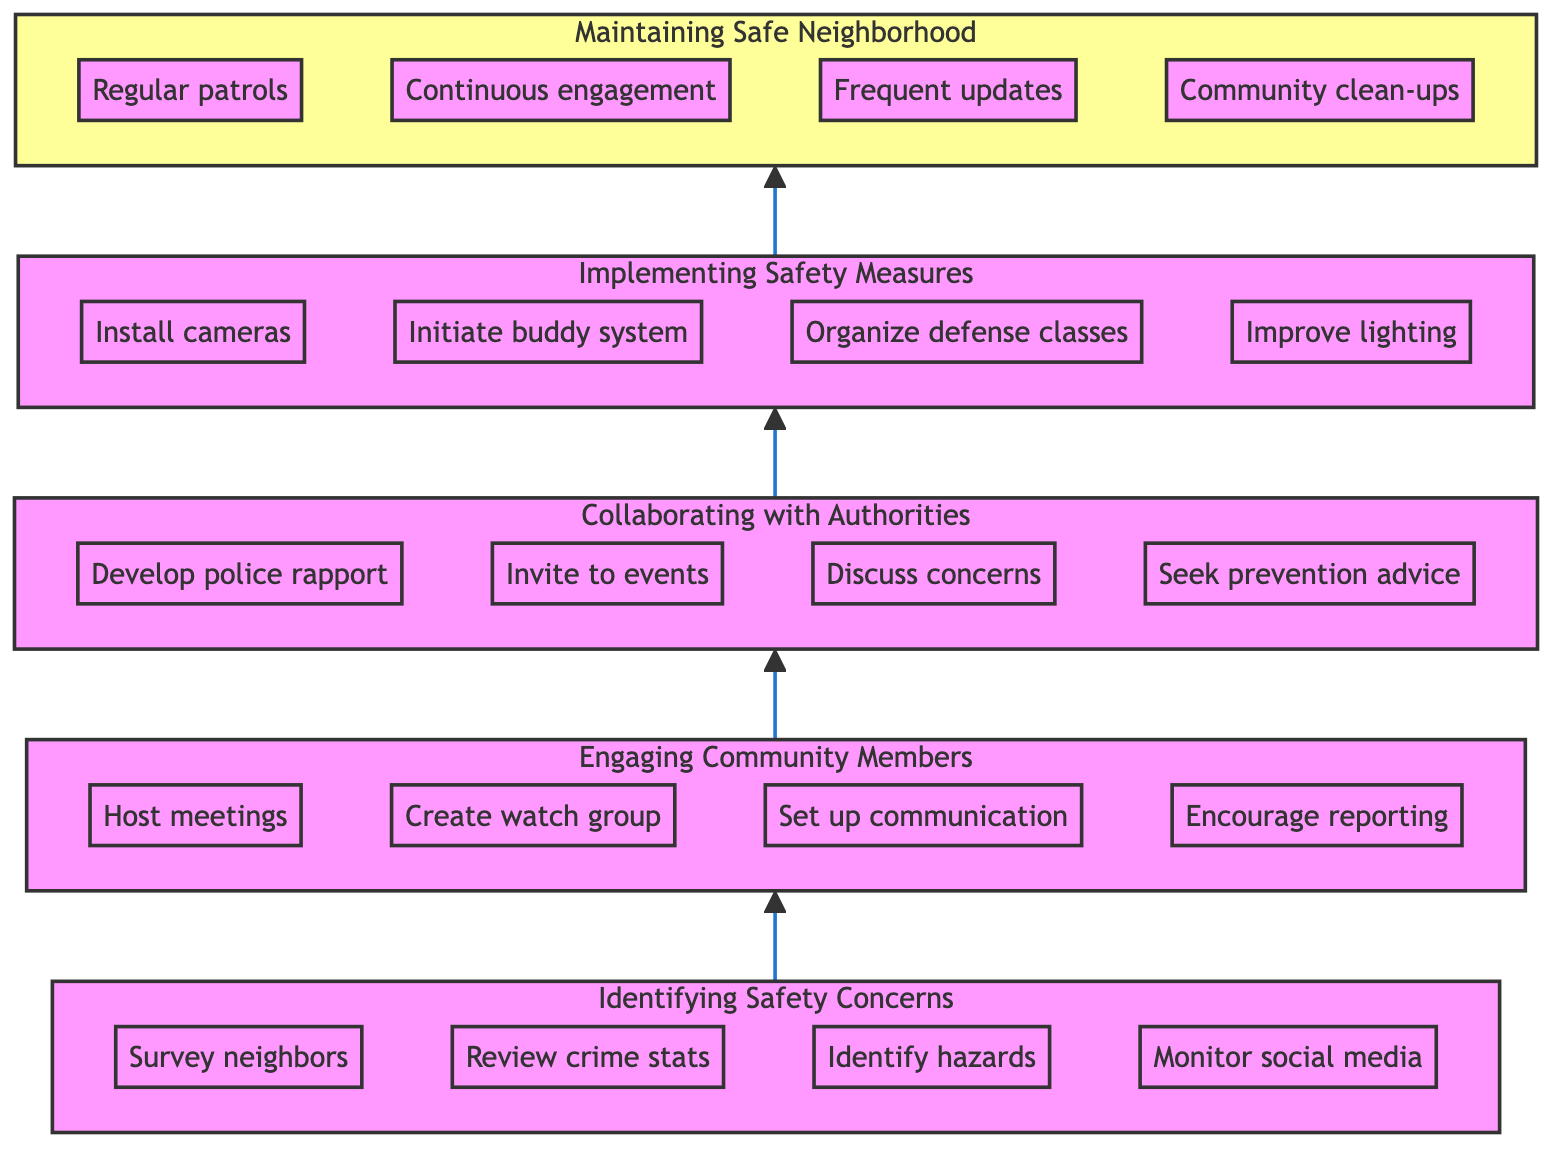What's the top node of the diagram? The top node of the diagram is "Maintaining a Safe Neighborhood," which is the final goal of the flow chart.
Answer: Maintaining a Safe Neighborhood How many nodes are in total in the diagram? The diagram consists of five main nodes: Identifying Safety Concerns, Engaging Community Members, Collaborating with Local Authorities, Developing and Implementing Safety Measures, and Maintaining a Safe Neighborhood.
Answer: 5 What is the relationship between "Engaging Community Members" and "Collaborating with Local Authorities"? "Engaging Community Members" leads directly to "Collaborating with Local Authorities," signifying a progression from community engagement to working with police and officials for enhanced safety.
Answer: Direct relationship Which node comes immediately before "Developing and Implementing Safety Measures"? The node that comes immediately before "Developing and Implementing Safety Measures" is "Collaborating with Local Authorities," indicating that collaboration precedes the development of specific safety measures.
Answer: Collaborating with Local Authorities Name one action listed under "Identifying Safety Concerns." One action listed under "Identifying Safety Concerns" is "Survey neighbors about feeling of safety," which involves gathering direct feedback from the community regarding safety perceptions.
Answer: Survey neighbors about feeling of safety How do "Regular patrols" relate to the overall goal of the diagram? "Regular patrols" are a part of the "Maintaining a Safe Neighborhood" efforts that help ensure ongoing safety, showing that active measures are taken after implementing safety measures.
Answer: Ongoing safety What is the first step outlined in the flow chart? The flow chart starts with "Identifying Safety Concerns," representing the essential initial step in enhancing neighborhood safety before any further actions are taken.
Answer: Identifying Safety Concerns Is it necessary to engage community members before collaborating with local authorities? Yes, engaging community members is necessary as it establishes a foundation of communication and shared concerns, which are vital before approaching local authorities for collaboration.
Answer: Yes List an example of a safety measure to be developed and implemented. An example of a safety measure is "Install neighborhood surveillance cameras," which enhances monitoring and contributes to deterring crime in the area.
Answer: Install neighborhood surveillance cameras 